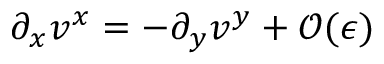<formula> <loc_0><loc_0><loc_500><loc_500>\partial _ { x } { v ^ { x } } = - \partial _ { y } { v ^ { y } } + { \mathcal { O } } ( { \epsilon } )</formula> 